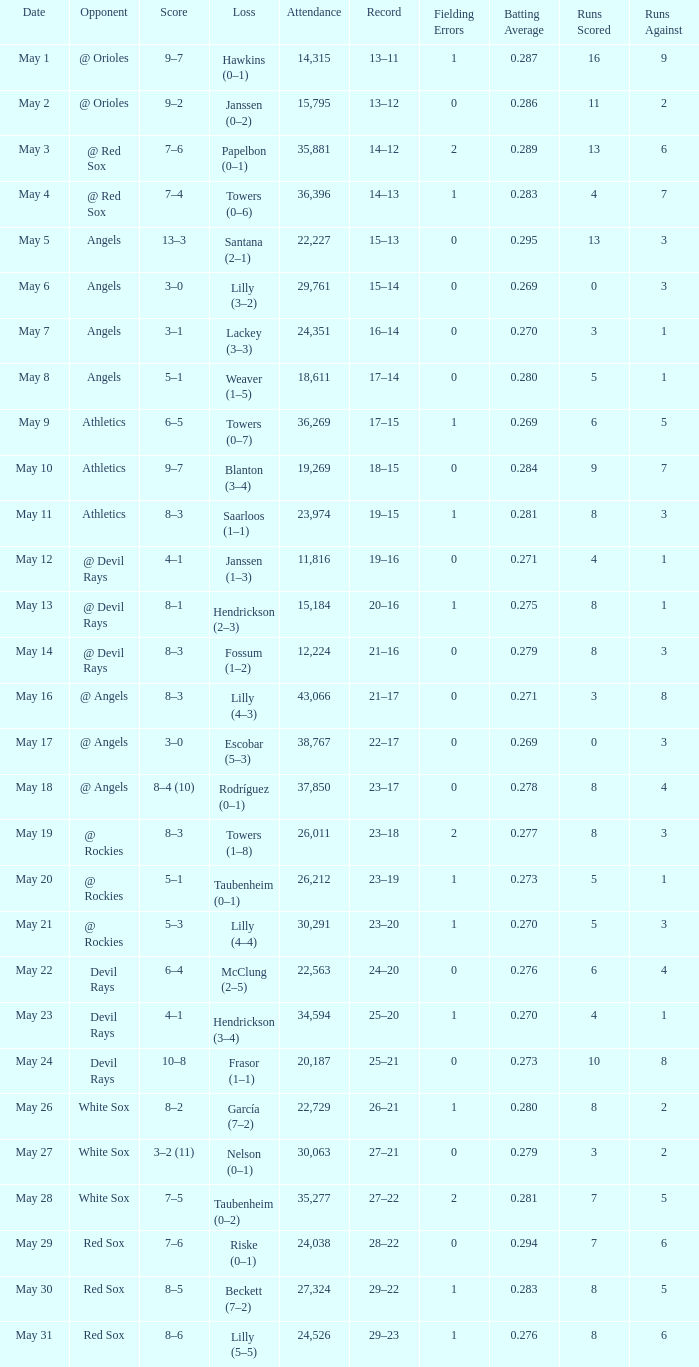When the team had their record of 16–14, what was the total attendance? 1.0. 